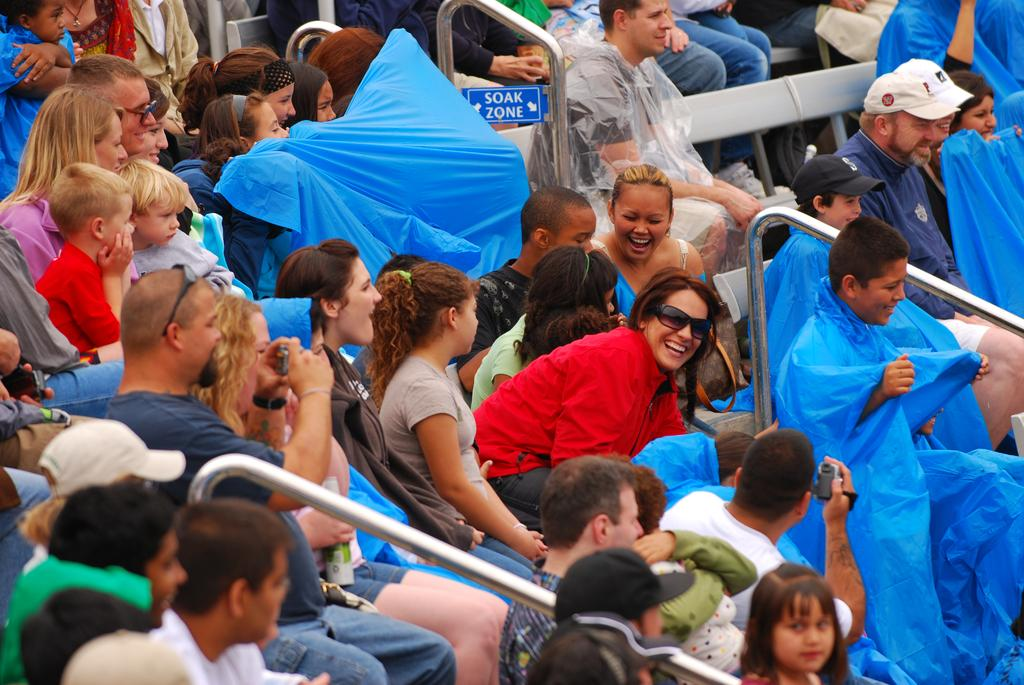What is happening in the image? There is a group of people in the image. What are the people doing in the image? The people are sitting on chairs. Are there any objects being held by the people? Some people are holding cameras. What color are the plastic covers visible in the image? The plastic covers are blue. What type of soup is being served at the show in the image? There is no soup or show present in the image; it features a group of people sitting on chairs with some holding cameras. 